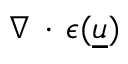Convert formula to latex. <formula><loc_0><loc_0><loc_500><loc_500>\nabla \, \cdot \, \epsilon ( \underline { u } )</formula> 